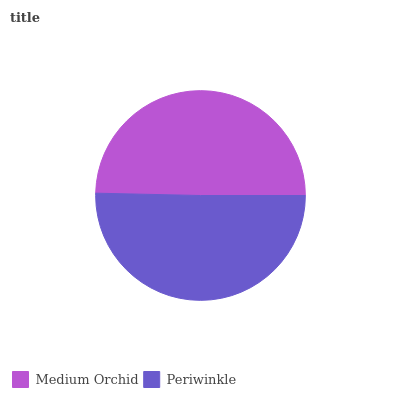Is Medium Orchid the minimum?
Answer yes or no. Yes. Is Periwinkle the maximum?
Answer yes or no. Yes. Is Periwinkle the minimum?
Answer yes or no. No. Is Periwinkle greater than Medium Orchid?
Answer yes or no. Yes. Is Medium Orchid less than Periwinkle?
Answer yes or no. Yes. Is Medium Orchid greater than Periwinkle?
Answer yes or no. No. Is Periwinkle less than Medium Orchid?
Answer yes or no. No. Is Periwinkle the high median?
Answer yes or no. Yes. Is Medium Orchid the low median?
Answer yes or no. Yes. Is Medium Orchid the high median?
Answer yes or no. No. Is Periwinkle the low median?
Answer yes or no. No. 